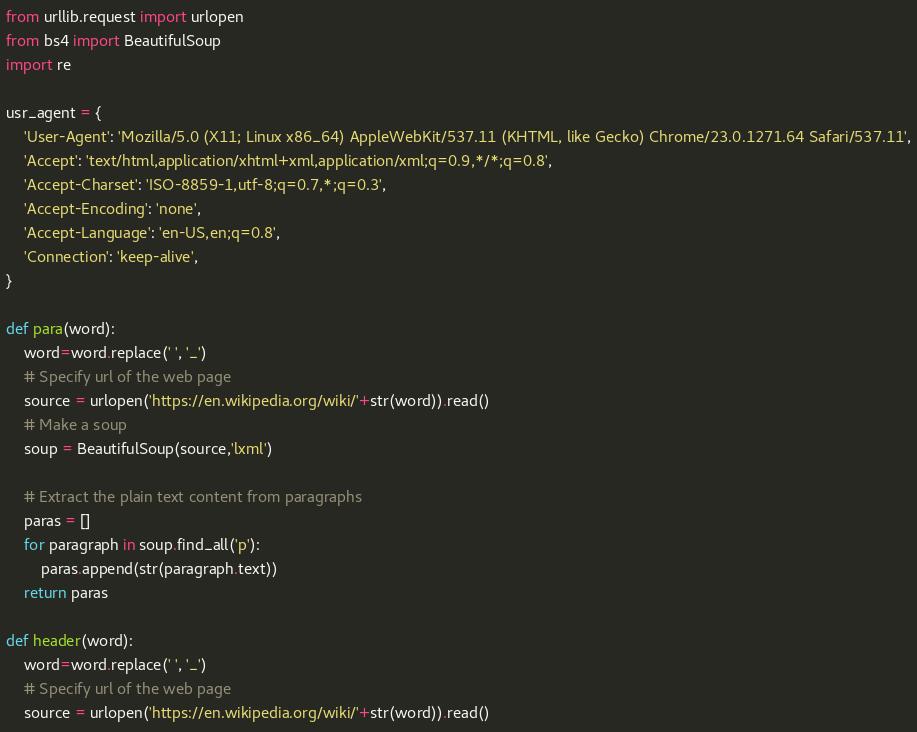Convert code to text. <code><loc_0><loc_0><loc_500><loc_500><_Python_>from urllib.request import urlopen
from bs4 import BeautifulSoup
import re

usr_agent = {
    'User-Agent': 'Mozilla/5.0 (X11; Linux x86_64) AppleWebKit/537.11 (KHTML, like Gecko) Chrome/23.0.1271.64 Safari/537.11',
    'Accept': 'text/html,application/xhtml+xml,application/xml;q=0.9,*/*;q=0.8',
    'Accept-Charset': 'ISO-8859-1,utf-8;q=0.7,*;q=0.3',
    'Accept-Encoding': 'none',
    'Accept-Language': 'en-US,en;q=0.8',
    'Connection': 'keep-alive',
}

def para(word):
    word=word.replace(' ', '_')
    # Specify url of the web page
    source = urlopen('https://en.wikipedia.org/wiki/'+str(word)).read()
    # Make a soup 
    soup = BeautifulSoup(source,'lxml')

    # Extract the plain text content from paragraphs
    paras = []
    for paragraph in soup.find_all('p'):
        paras.append(str(paragraph.text))
    return paras

def header(word):
    word=word.replace(' ', '_')
    # Specify url of the web page
    source = urlopen('https://en.wikipedia.org/wiki/'+str(word)).read()</code> 